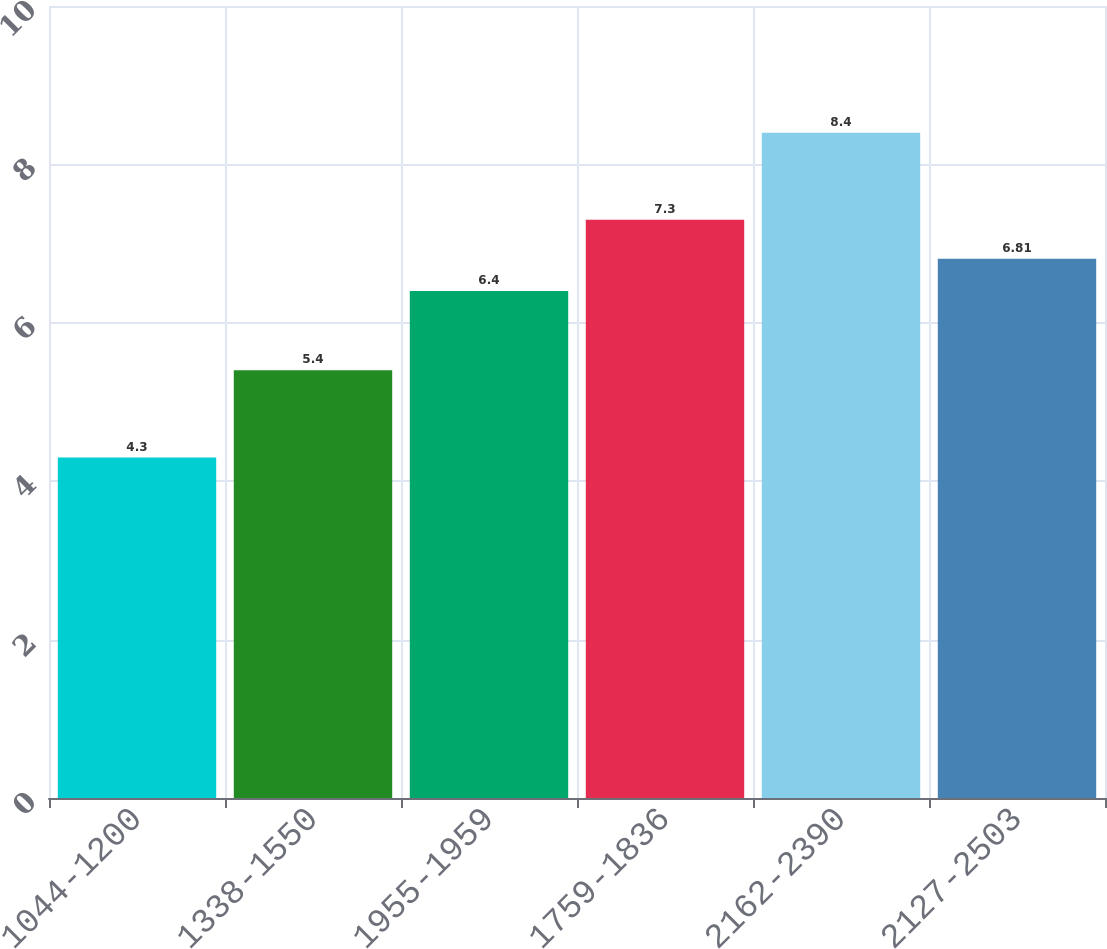<chart> <loc_0><loc_0><loc_500><loc_500><bar_chart><fcel>1044-1200<fcel>1338-1550<fcel>1955-1959<fcel>1759-1836<fcel>2162-2390<fcel>2127-2503<nl><fcel>4.3<fcel>5.4<fcel>6.4<fcel>7.3<fcel>8.4<fcel>6.81<nl></chart> 